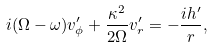Convert formula to latex. <formula><loc_0><loc_0><loc_500><loc_500>i ( \Omega - \omega ) v _ { \phi } ^ { \prime } + \frac { \kappa ^ { 2 } } { 2 \Omega } v _ { r } ^ { \prime } = - \frac { i h ^ { \prime } } { r } ,</formula> 